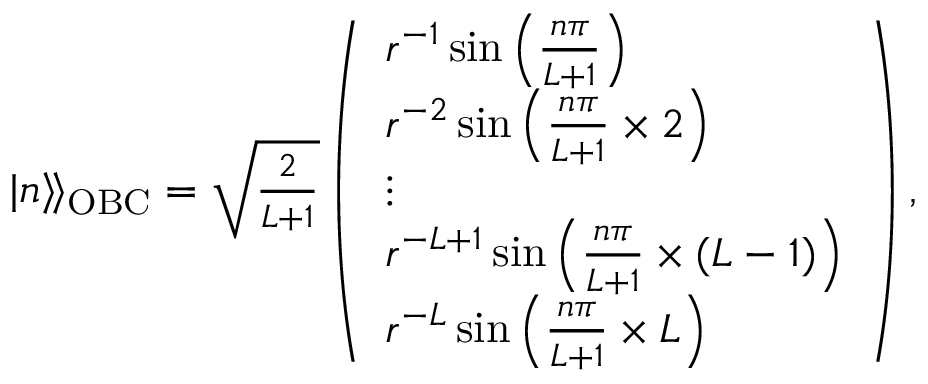Convert formula to latex. <formula><loc_0><loc_0><loc_500><loc_500>\begin{array} { r } { | n \rangle \, \rangle _ { O B C } = \sqrt { \frac { 2 } { L + 1 } } \left ( \begin{array} { l } { r ^ { - 1 } \sin { \left ( \frac { n \pi } { L + 1 } \right ) } } \\ { r ^ { - 2 } \sin { \left ( \frac { n \pi } { L + 1 } \times 2 \right ) } } \\ { \vdots } \\ { r ^ { - L + 1 } \sin { \left ( \frac { n \pi } { L + 1 } \times ( L - 1 ) \right ) } } \\ { r ^ { - L } \sin { \left ( \frac { n \pi } { L + 1 } \times L \right ) } } \end{array} \right ) , } \end{array}</formula> 